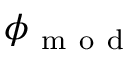Convert formula to latex. <formula><loc_0><loc_0><loc_500><loc_500>\phi _ { m o d }</formula> 